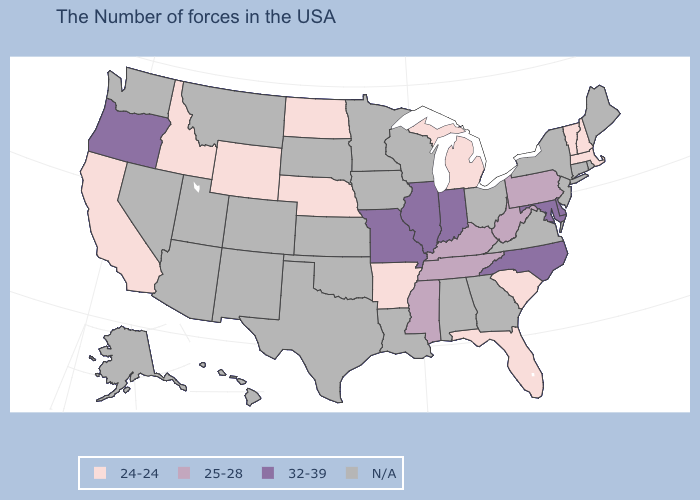Name the states that have a value in the range 32-39?
Keep it brief. Delaware, Maryland, North Carolina, Indiana, Illinois, Missouri, Oregon. What is the value of Missouri?
Be succinct. 32-39. Which states have the lowest value in the USA?
Keep it brief. Massachusetts, New Hampshire, Vermont, South Carolina, Florida, Michigan, Arkansas, Nebraska, North Dakota, Wyoming, Idaho, California. Among the states that border Texas , which have the highest value?
Answer briefly. Arkansas. What is the highest value in states that border Arizona?
Quick response, please. 24-24. What is the value of Connecticut?
Short answer required. N/A. Name the states that have a value in the range 24-24?
Short answer required. Massachusetts, New Hampshire, Vermont, South Carolina, Florida, Michigan, Arkansas, Nebraska, North Dakota, Wyoming, Idaho, California. What is the value of Colorado?
Be succinct. N/A. Name the states that have a value in the range 24-24?
Short answer required. Massachusetts, New Hampshire, Vermont, South Carolina, Florida, Michigan, Arkansas, Nebraska, North Dakota, Wyoming, Idaho, California. What is the lowest value in states that border West Virginia?
Short answer required. 25-28. Which states have the lowest value in the USA?
Keep it brief. Massachusetts, New Hampshire, Vermont, South Carolina, Florida, Michigan, Arkansas, Nebraska, North Dakota, Wyoming, Idaho, California. Name the states that have a value in the range 32-39?
Concise answer only. Delaware, Maryland, North Carolina, Indiana, Illinois, Missouri, Oregon. 